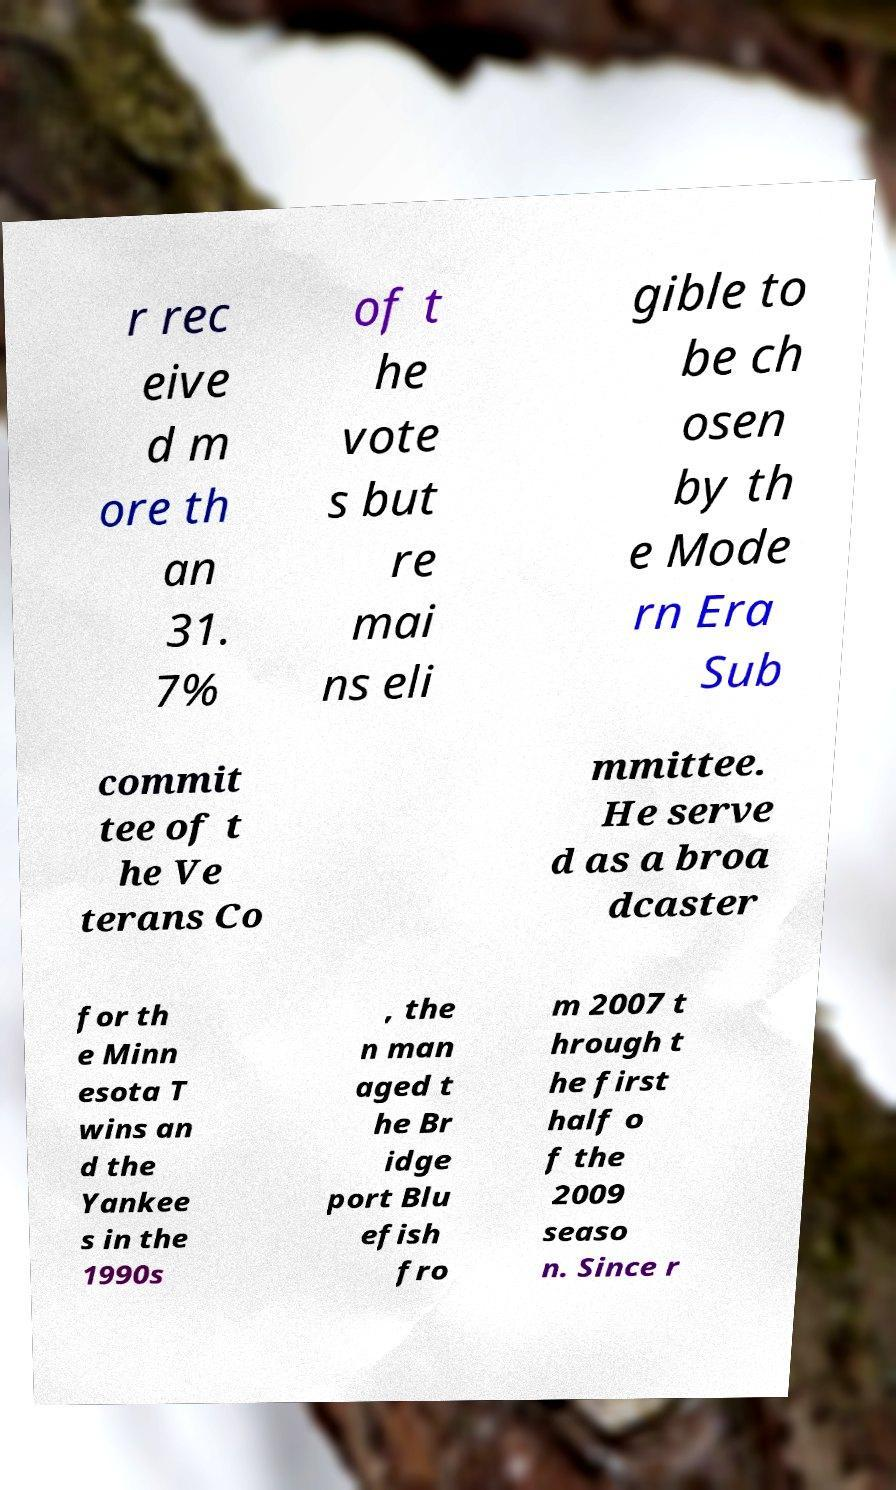Can you accurately transcribe the text from the provided image for me? r rec eive d m ore th an 31. 7% of t he vote s but re mai ns eli gible to be ch osen by th e Mode rn Era Sub commit tee of t he Ve terans Co mmittee. He serve d as a broa dcaster for th e Minn esota T wins an d the Yankee s in the 1990s , the n man aged t he Br idge port Blu efish fro m 2007 t hrough t he first half o f the 2009 seaso n. Since r 